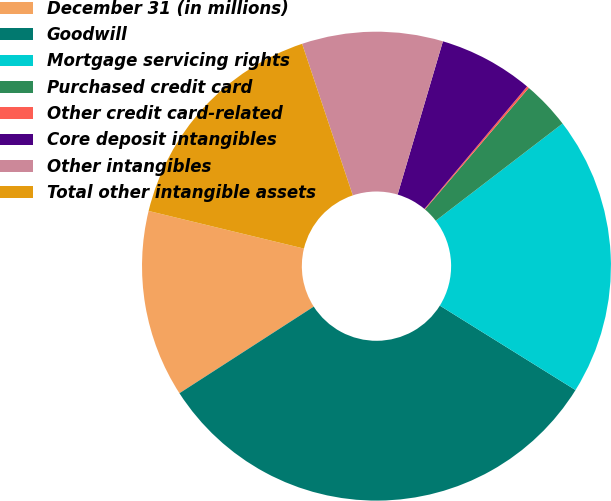<chart> <loc_0><loc_0><loc_500><loc_500><pie_chart><fcel>December 31 (in millions)<fcel>Goodwill<fcel>Mortgage servicing rights<fcel>Purchased credit card<fcel>Other credit card-related<fcel>Core deposit intangibles<fcel>Other intangibles<fcel>Total other intangible assets<nl><fcel>12.9%<fcel>32.02%<fcel>19.27%<fcel>3.34%<fcel>0.15%<fcel>6.53%<fcel>9.71%<fcel>16.08%<nl></chart> 